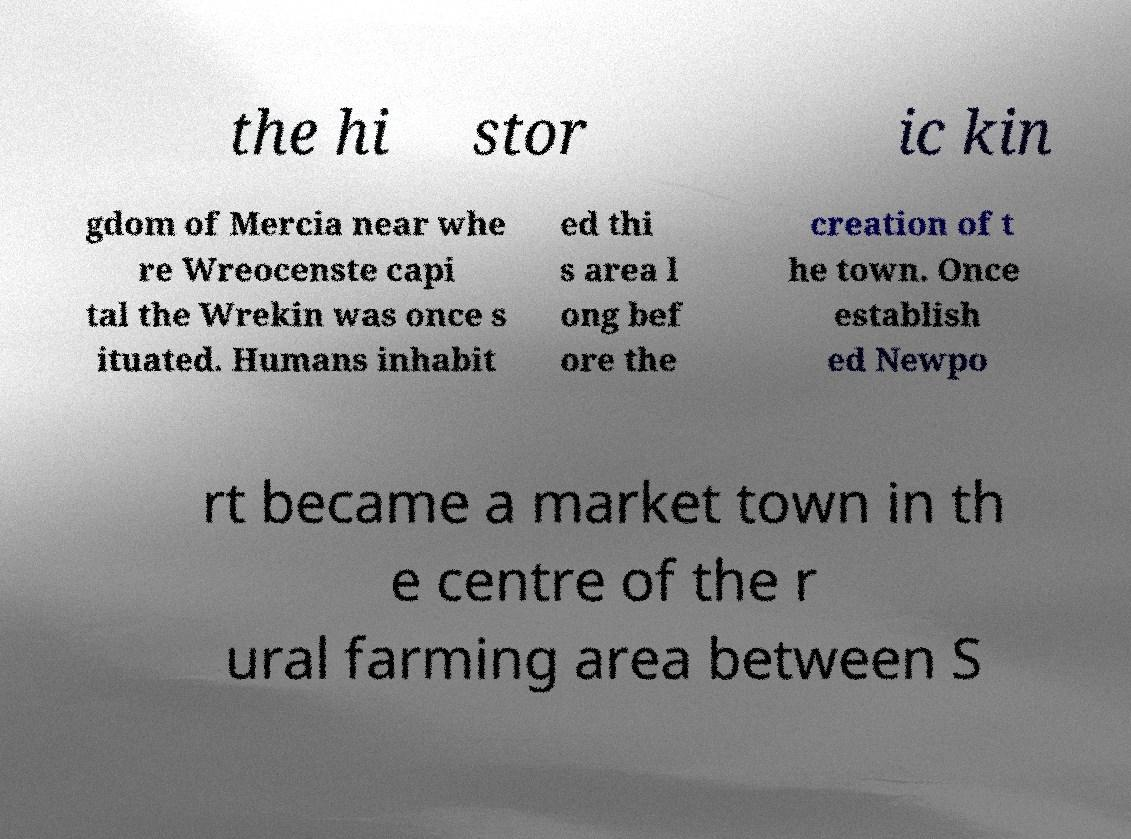Could you extract and type out the text from this image? the hi stor ic kin gdom of Mercia near whe re Wreocenste capi tal the Wrekin was once s ituated. Humans inhabit ed thi s area l ong bef ore the creation of t he town. Once establish ed Newpo rt became a market town in th e centre of the r ural farming area between S 